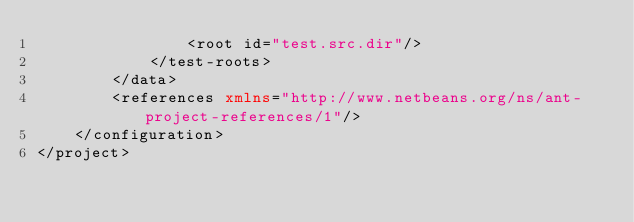<code> <loc_0><loc_0><loc_500><loc_500><_XML_>                <root id="test.src.dir"/>
            </test-roots>
        </data>
        <references xmlns="http://www.netbeans.org/ns/ant-project-references/1"/>
    </configuration>
</project>
</code> 